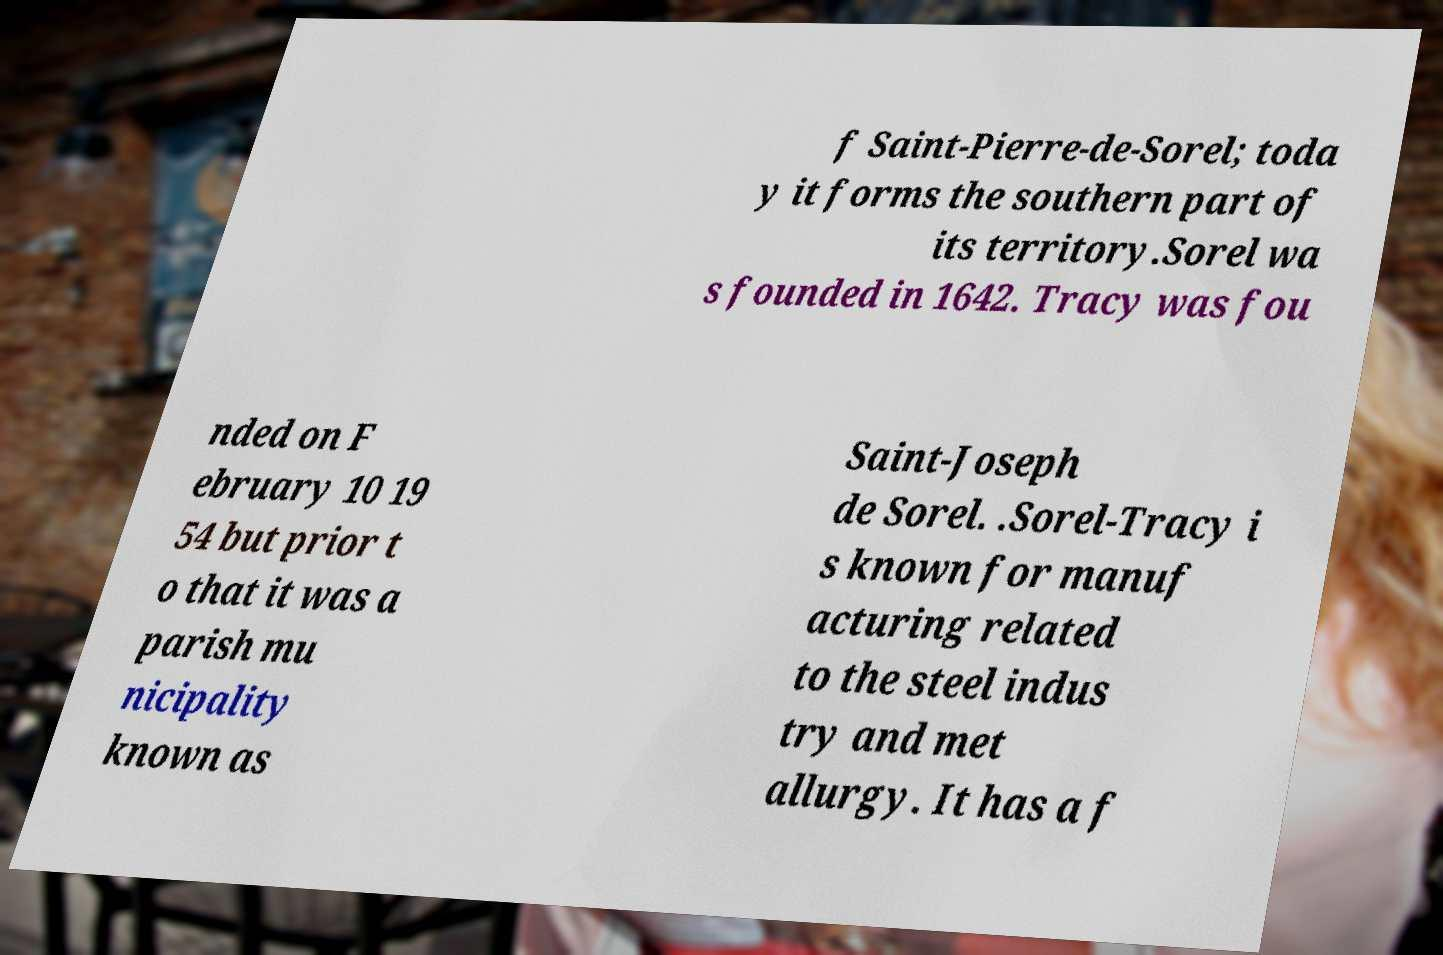Could you assist in decoding the text presented in this image and type it out clearly? f Saint-Pierre-de-Sorel; toda y it forms the southern part of its territory.Sorel wa s founded in 1642. Tracy was fou nded on F ebruary 10 19 54 but prior t o that it was a parish mu nicipality known as Saint-Joseph de Sorel. .Sorel-Tracy i s known for manuf acturing related to the steel indus try and met allurgy. It has a f 